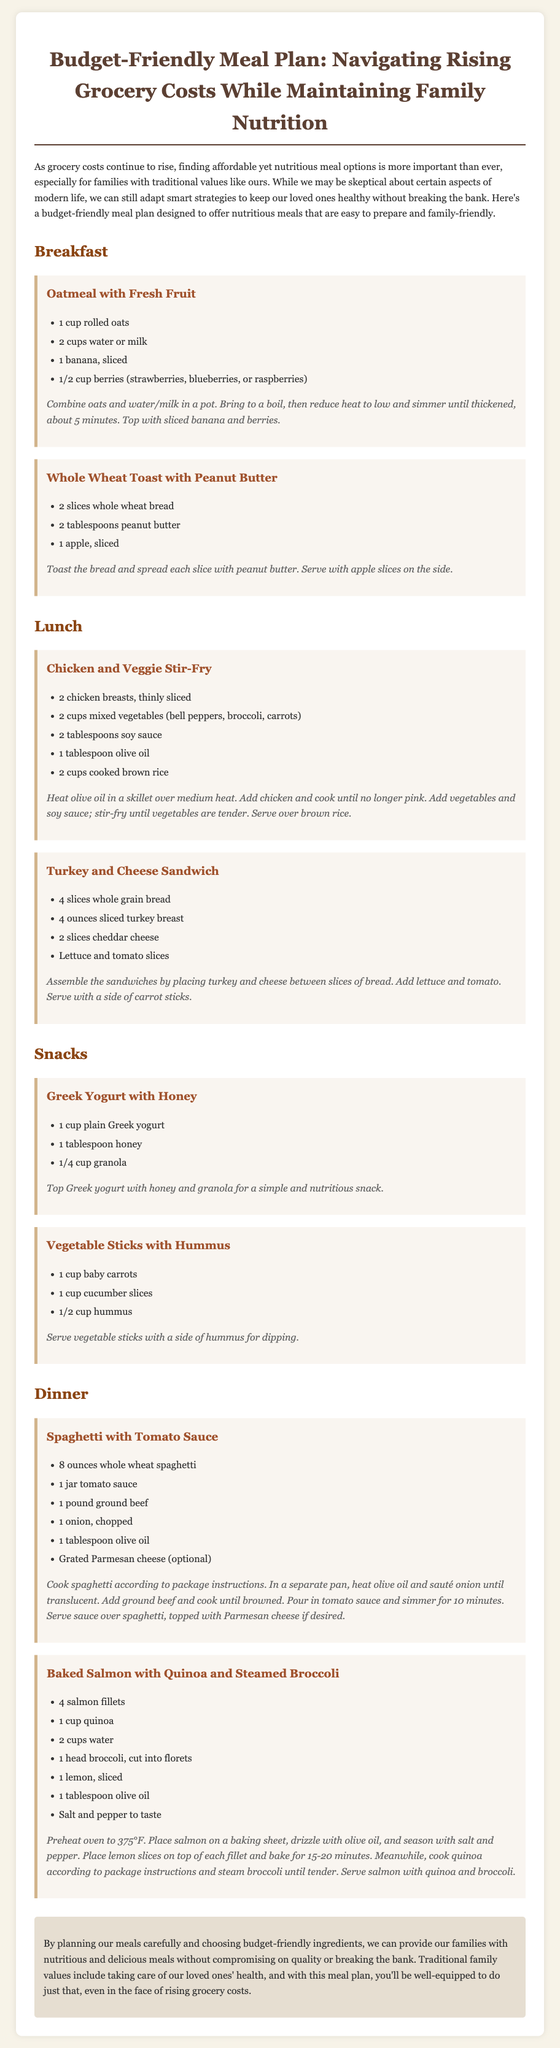What is the title of the document? The title of the document is the main heading found at the top of the content.
Answer: Budget-Friendly Meal Plan: Navigating Rising Grocery Costs While Maintaining Family Nutrition How many meals are listed in the dinner section? The dinner section includes the meals listed below the heading for dinner, which shows two meals.
Answer: 2 What ingredient is needed for the oatmeal recipe? The oatmeal recipe lists essential ingredients that are needed, one of which is rolled oats.
Answer: Rolled oats What type of bread is used in the turkey and cheese sandwich? The type of bread is specified in the list of ingredients for that sandwich recipe.
Answer: Whole grain bread How many tablespoons of peanut butter are required for the toast? The peanut butter requirement is mentioned in the ingredients list of the whole wheat toast.
Answer: 2 tablespoons Which meal includes salmon as an ingredient? By checking the dinner section, the meal containing salmon can be identified.
Answer: Baked Salmon with Quinoa and Steamed Broccoli What is suggested as a snack involving Greek yogurt? The snack involving Greek yogurt is explicitly mentioned in the snacks section.
Answer: Greek Yogurt with Honey How long should the baked salmon be cooked? The cooking time for the baked salmon is mentioned in the instructions for that meal.
Answer: 15-20 minutes What vegetable is used as a side in the baked salmon meal? The vegetable that accompanies the salmon is noted in the ingredients.
Answer: Broccoli 